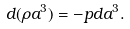Convert formula to latex. <formula><loc_0><loc_0><loc_500><loc_500>d ( \rho a ^ { 3 } ) = - p d a ^ { 3 } .</formula> 